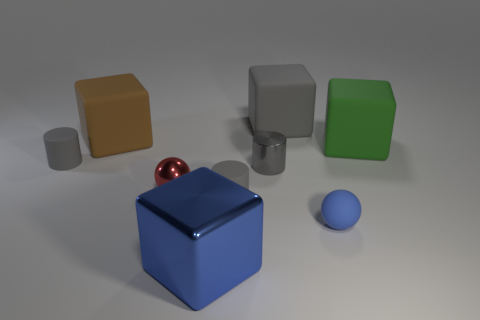The big thing that is the same color as the tiny matte ball is what shape?
Offer a terse response. Cube. Is the material of the big brown thing behind the blue sphere the same as the tiny blue thing?
Ensure brevity in your answer.  Yes. What number of tiny yellow metal things are there?
Your response must be concise. 0. How many things are either big brown cylinders or blue shiny blocks?
Keep it short and to the point. 1. There is a gray rubber block right of the gray shiny thing that is in front of the big green matte object; how many small metallic spheres are left of it?
Your answer should be compact. 1. Is there anything else of the same color as the tiny shiny cylinder?
Provide a succinct answer. Yes. Does the small sphere on the right side of the big metal cube have the same color as the rubber cylinder on the right side of the red sphere?
Your answer should be compact. No. Are there more large blue blocks behind the large green block than tiny balls on the right side of the big gray matte cube?
Provide a short and direct response. No. What is the material of the big brown cube?
Your answer should be compact. Rubber. There is a small rubber thing that is to the left of the gray object in front of the small metallic object that is to the left of the large blue cube; what is its shape?
Give a very brief answer. Cylinder. 